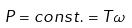<formula> <loc_0><loc_0><loc_500><loc_500>P = c o n s t . = T \omega</formula> 